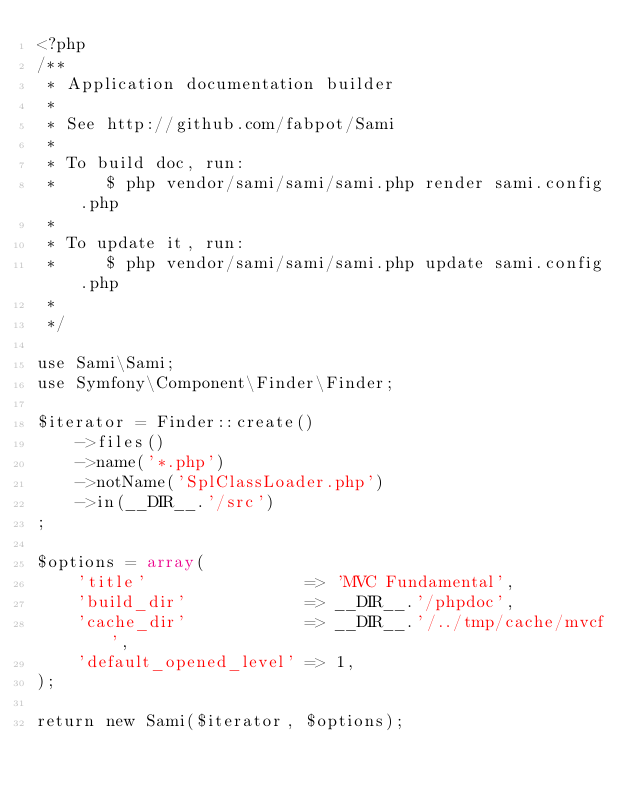<code> <loc_0><loc_0><loc_500><loc_500><_PHP_><?php
/**
 * Application documentation builder
 *
 * See http://github.com/fabpot/Sami
 *
 * To build doc, run:
 *     $ php vendor/sami/sami/sami.php render sami.config.php
 *
 * To update it, run:
 *     $ php vendor/sami/sami/sami.php update sami.config.php
 *
 */

use Sami\Sami;
use Symfony\Component\Finder\Finder;

$iterator = Finder::create()
    ->files()
    ->name('*.php')
    ->notName('SplClassLoader.php')
    ->in(__DIR__.'/src')
;

$options = array(
    'title'                => 'MVC Fundamental',
    'build_dir'            => __DIR__.'/phpdoc',
    'cache_dir'            => __DIR__.'/../tmp/cache/mvcf',
    'default_opened_level' => 1,
);

return new Sami($iterator, $options);

</code> 